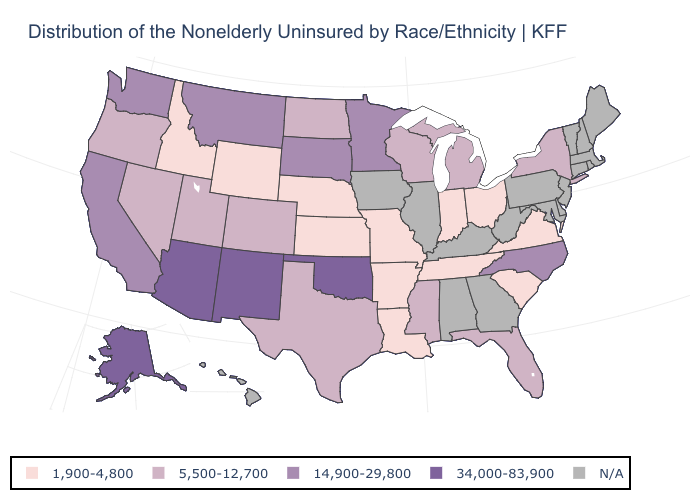What is the lowest value in the USA?
Answer briefly. 1,900-4,800. Is the legend a continuous bar?
Be succinct. No. Does the first symbol in the legend represent the smallest category?
Short answer required. Yes. Name the states that have a value in the range 1,900-4,800?
Write a very short answer. Arkansas, Idaho, Indiana, Kansas, Louisiana, Missouri, Nebraska, Ohio, South Carolina, Tennessee, Virginia, Wyoming. Name the states that have a value in the range N/A?
Write a very short answer. Alabama, Connecticut, Delaware, Georgia, Hawaii, Illinois, Iowa, Kentucky, Maine, Maryland, Massachusetts, New Hampshire, New Jersey, Pennsylvania, Rhode Island, Vermont, West Virginia. What is the value of Hawaii?
Keep it brief. N/A. Does Tennessee have the lowest value in the USA?
Give a very brief answer. Yes. What is the value of New Jersey?
Be succinct. N/A. What is the value of Maryland?
Be succinct. N/A. Does the first symbol in the legend represent the smallest category?
Short answer required. Yes. What is the lowest value in the MidWest?
Be succinct. 1,900-4,800. Name the states that have a value in the range 14,900-29,800?
Be succinct. California, Minnesota, Montana, North Carolina, South Dakota, Washington. Among the states that border Kansas , which have the lowest value?
Be succinct. Missouri, Nebraska. How many symbols are there in the legend?
Keep it brief. 5. How many symbols are there in the legend?
Quick response, please. 5. 